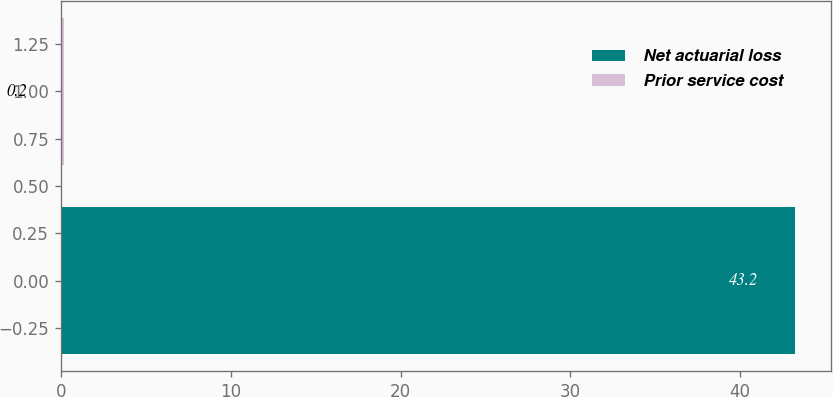Convert chart. <chart><loc_0><loc_0><loc_500><loc_500><bar_chart><fcel>Net actuarial loss<fcel>Prior service cost<nl><fcel>43.2<fcel>0.2<nl></chart> 